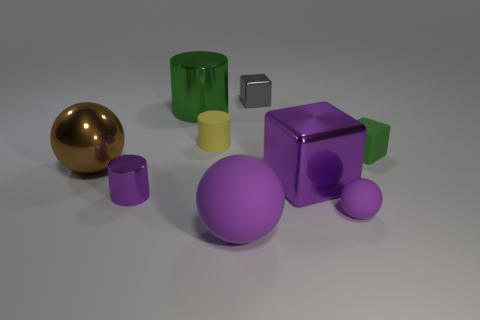What shape is the metallic thing that is both in front of the tiny green rubber object and behind the purple cube?
Offer a very short reply. Sphere. There is a cylinder on the left side of the green cylinder; what color is it?
Keep it short and to the point. Purple. What size is the metallic object that is in front of the green cylinder and to the right of the large green metallic cylinder?
Provide a succinct answer. Large. Do the green block and the big sphere in front of the brown ball have the same material?
Give a very brief answer. Yes. How many large yellow metal things have the same shape as the small green thing?
Ensure brevity in your answer.  0. What material is the tiny thing that is the same color as the large cylinder?
Your answer should be very brief. Rubber. How many small gray metallic objects are there?
Provide a succinct answer. 1. Is the shape of the tiny purple matte thing the same as the purple metallic object on the right side of the tiny metal block?
Your answer should be very brief. No. How many objects are either small green metallic cylinders or large metallic things that are to the right of the small purple cylinder?
Keep it short and to the point. 2. What is the material of the big purple object that is the same shape as the gray thing?
Provide a succinct answer. Metal. 